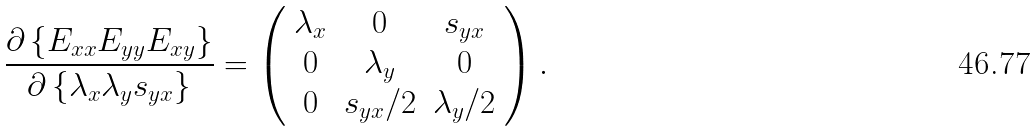Convert formula to latex. <formula><loc_0><loc_0><loc_500><loc_500>\frac { \partial \left \{ E _ { x x } E _ { y y } E _ { x y } \right \} } { \partial \left \{ \lambda _ { x } \lambda _ { y } s _ { y x } \right \} } = \left ( \begin{array} { c c c } \lambda _ { x } & 0 & s _ { y x } \\ 0 & \lambda _ { y } & 0 \\ 0 & s _ { y x } / 2 & \lambda _ { y } / 2 \end{array} \right ) .</formula> 